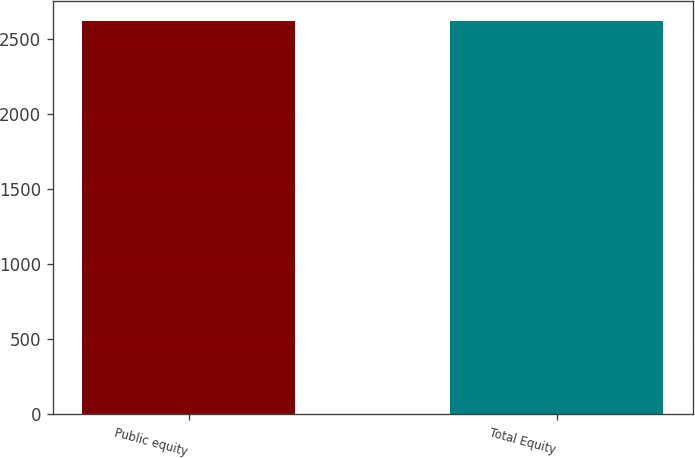Convert chart to OTSL. <chart><loc_0><loc_0><loc_500><loc_500><bar_chart><fcel>Public equity<fcel>Total Equity<nl><fcel>2616<fcel>2620<nl></chart> 